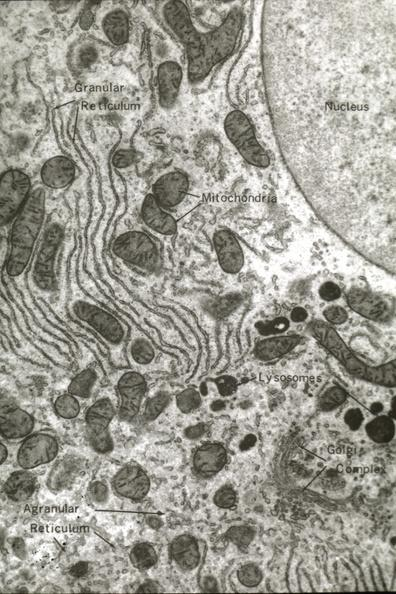s uterus present?
Answer the question using a single word or phrase. No 